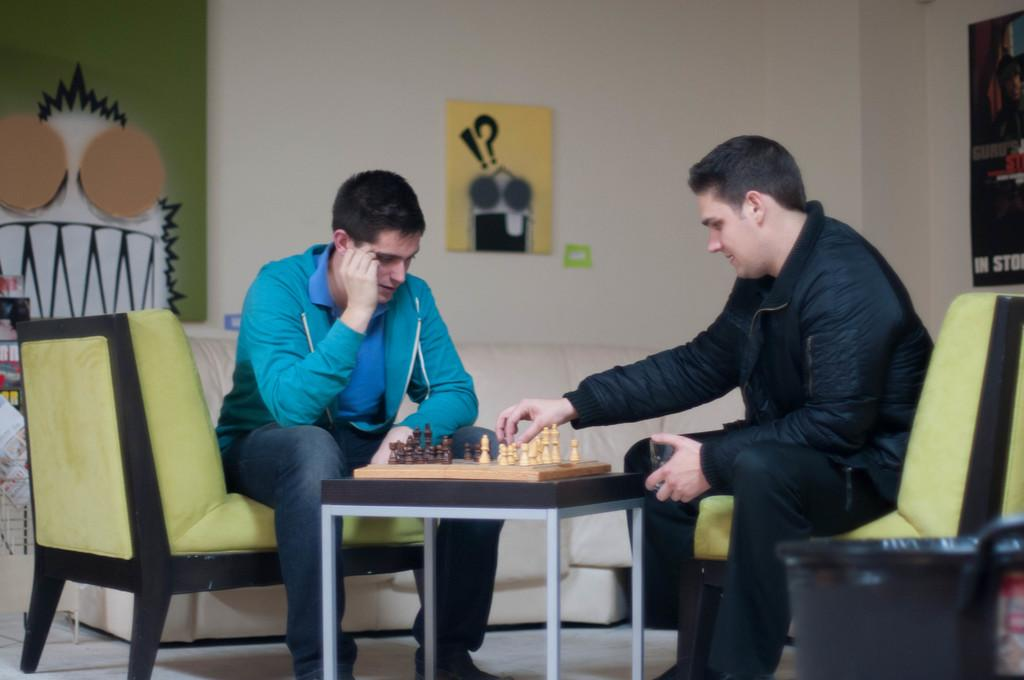How many people are in the image? There are two men in the image. What are the men doing in the image? The men are playing chess. What are the men sitting on in the image? The men are sitting on chairs. What is near the men in the image? The men are near a table. What can be seen on the wall in the background of the image? There are two paintings on the wall. Can you hear the men talking in the image? The image is silent, so we cannot hear the men talking. What time of day is it in the image? The image does not provide any information about the time of day, so we cannot determine if it is night or day. 